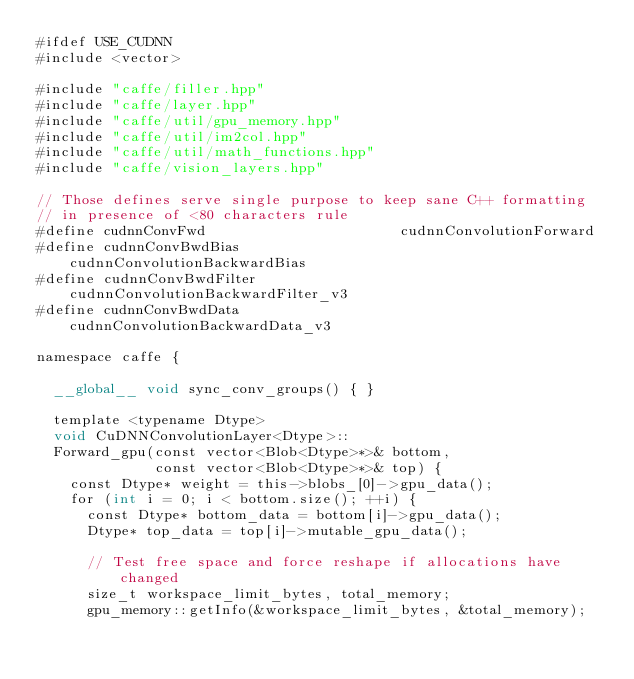Convert code to text. <code><loc_0><loc_0><loc_500><loc_500><_Cuda_>#ifdef USE_CUDNN
#include <vector>

#include "caffe/filler.hpp"
#include "caffe/layer.hpp"
#include "caffe/util/gpu_memory.hpp"
#include "caffe/util/im2col.hpp"
#include "caffe/util/math_functions.hpp"
#include "caffe/vision_layers.hpp"

// Those defines serve single purpose to keep sane C++ formatting
// in presence of <80 characters rule
#define cudnnConvFwd                       cudnnConvolutionForward
#define cudnnConvBwdBias                   cudnnConvolutionBackwardBias
#define cudnnConvBwdFilter                 cudnnConvolutionBackwardFilter_v3
#define cudnnConvBwdData                   cudnnConvolutionBackwardData_v3

namespace caffe {

  __global__ void sync_conv_groups() { }

  template <typename Dtype>
  void CuDNNConvolutionLayer<Dtype>::
  Forward_gpu(const vector<Blob<Dtype>*>& bottom,
              const vector<Blob<Dtype>*>& top) {
    const Dtype* weight = this->blobs_[0]->gpu_data();
    for (int i = 0; i < bottom.size(); ++i) {
      const Dtype* bottom_data = bottom[i]->gpu_data();
      Dtype* top_data = top[i]->mutable_gpu_data();

      // Test free space and force reshape if allocations have changed
      size_t workspace_limit_bytes, total_memory;
      gpu_memory::getInfo(&workspace_limit_bytes, &total_memory);</code> 